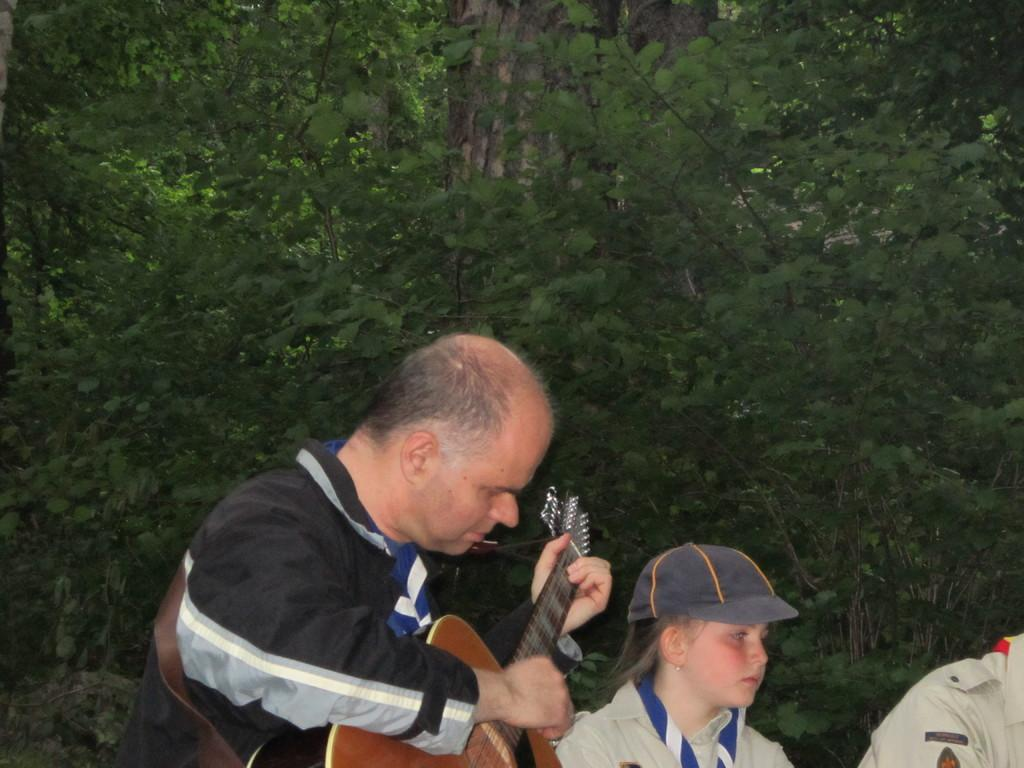What is the man in the image doing? The man is playing a guitar in the image. Who else is present in the image? There is a girl in the image. What is the girl wearing on her head? The girl is wearing a cap in the image. What type of dinosaur can be seen in the image? There are no dinosaurs present in the image; it features a man playing a guitar and a girl wearing a cap. 